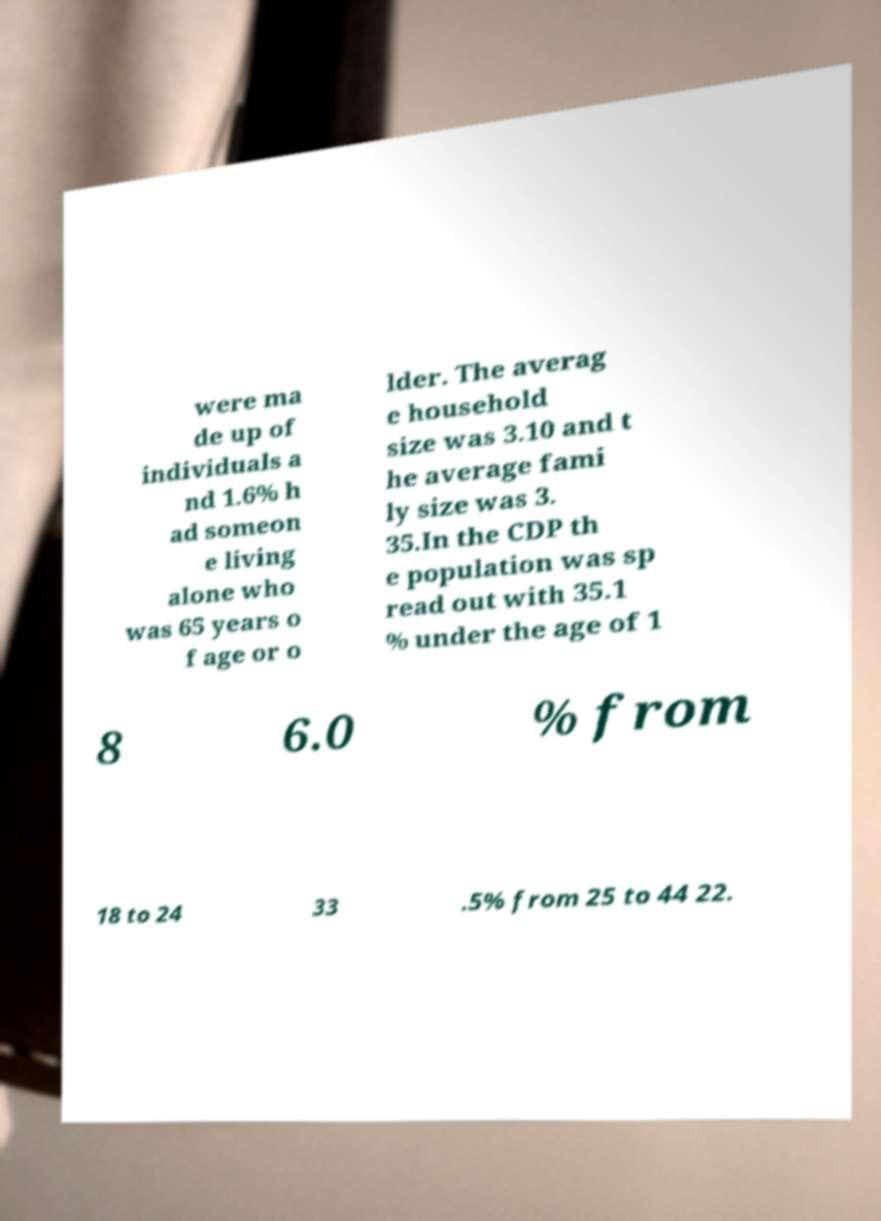Please identify and transcribe the text found in this image. were ma de up of individuals a nd 1.6% h ad someon e living alone who was 65 years o f age or o lder. The averag e household size was 3.10 and t he average fami ly size was 3. 35.In the CDP th e population was sp read out with 35.1 % under the age of 1 8 6.0 % from 18 to 24 33 .5% from 25 to 44 22. 